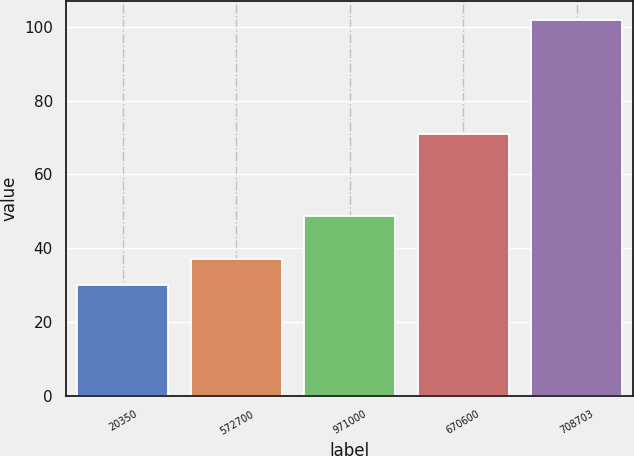Convert chart to OTSL. <chart><loc_0><loc_0><loc_500><loc_500><bar_chart><fcel>20350<fcel>572700<fcel>971000<fcel>670600<fcel>708703<nl><fcel>29.93<fcel>37.13<fcel>48.66<fcel>71.1<fcel>101.96<nl></chart> 